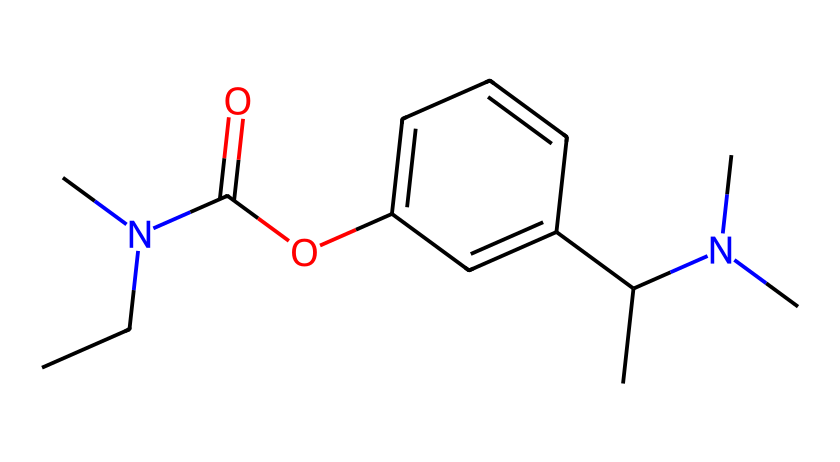What is the molecular formula of rivastigmine? To derive the molecular formula, we count the number of each type of atom present in the SMILES representation. The chemical structure contains 12 carbon (C) atoms, 16 hydrogen (H) atoms, 2 nitrogen (N) atoms, and 1 oxygen (O) atom. Therefore, the molecular formula is C12H16N2O.
Answer: C12H16N2O How many rings are present in the chemical structure? By analyzing the SMILES representation, we identify that there is one cyclic structure present in the compound, which is evident from the 'c' notation indicating aromatic carbon atoms, thus revealing one ring.
Answer: 1 What type of compound is rivastigmine? This compound can be classified as a carbamate due to the presence of the -C(=O)O- functional group, which is characteristic of carbamate structures.
Answer: carbamate What functional groups can be identified in this structure? Analyzing the SMILES representation, we can identify an ester (-C(=O)O-) and a secondary amine (-N(C)C) as the primary functional groups present in rivastigmine's structure.
Answer: ester and secondary amine What is the total number of nitrogen atoms in rivastigmine? Looking at the SMILES representation, we can see two nitrogen atoms. The presence of 'N' in the structure confirms this count.
Answer: 2 Which part of the structure is associated with its medicinal properties? The presence of the carbamate functional group (the -C(=O)O- part) is crucial as it is responsible for rivastigmine's mechanism of action in inhibiting acetylcholinesterase, which enhances cholinergic function.
Answer: carbamate functional group 